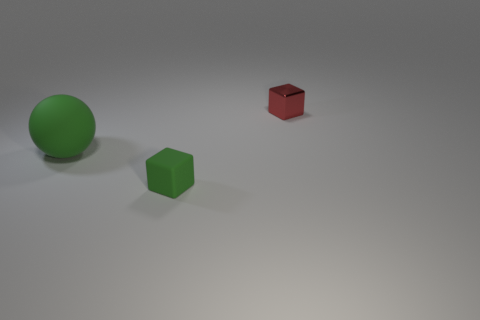Are there any other things that have the same material as the red block?
Provide a succinct answer. No. How big is the green matte sphere that is to the left of the tiny block that is on the right side of the small object that is to the left of the tiny shiny cube?
Give a very brief answer. Large. There is a block that is to the left of the red thing; how big is it?
Offer a terse response. Small. What is the shape of the green object that is made of the same material as the ball?
Keep it short and to the point. Cube. Does the thing that is to the left of the tiny green thing have the same material as the tiny green cube?
Your answer should be compact. Yes. How many other things are made of the same material as the big green sphere?
Your answer should be compact. 1. How many things are green rubber things to the right of the large object or objects in front of the green matte sphere?
Your answer should be compact. 1. There is a tiny thing that is in front of the tiny metallic thing; is it the same shape as the object left of the small matte thing?
Offer a terse response. No. What is the shape of the green thing that is the same size as the red metallic object?
Your response must be concise. Cube. How many metal objects are green objects or large brown cylinders?
Provide a succinct answer. 0. 